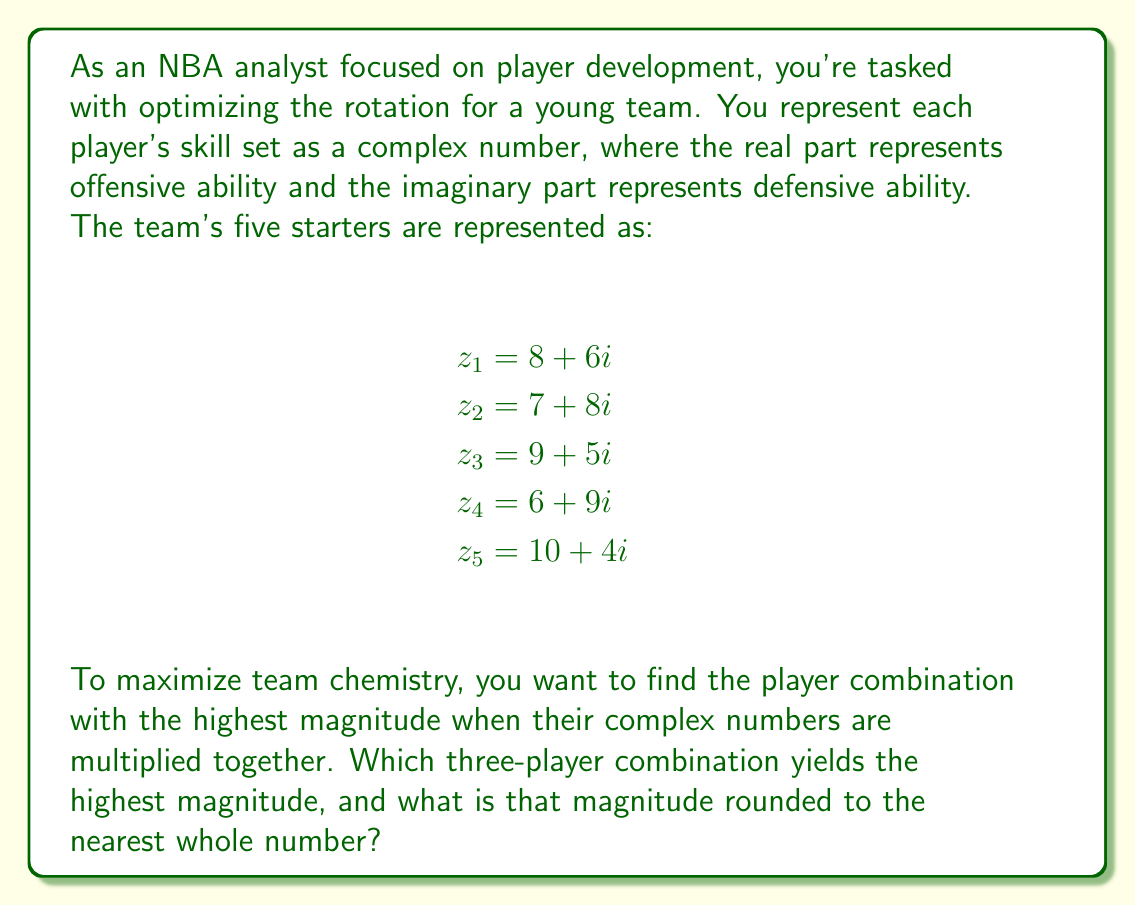Can you answer this question? To solve this problem, we need to:
1. Calculate the magnitude of each three-player combination
2. Compare the magnitudes to find the highest one

The magnitude of a complex number $z = a + bi$ is given by $|z| = \sqrt{a^2 + b^2}$

For a combination of three players, we multiply their complex numbers:
$(a_1 + b_1i)(a_2 + b_2i)(a_3 + b_3i) = (a_1a_2a_3 - a_1b_2b_3 - a_2b_1b_3 - a_3b_1b_2) + (a_1a_2b_3 + a_1a_3b_2 + a_2a_3b_1 - b_1b_2b_3)i$

Let's calculate for each combination:

1) $z_1, z_2, z_3$:
$(8+6i)(7+8i)(9+5i) = (-582 + 1494i)$
$|-582 + 1494i| = \sqrt{(-582)^2 + 1494^2} \approx 1604$

2) $z_1, z_2, z_4$:
$(8+6i)(7+8i)(6+9i) = (-1098 + 1062i)$
$|-1098 + 1062i| = \sqrt{(-1098)^2 + 1062^2} \approx 1526$

3) $z_1, z_2, z_5$:
$(8+6i)(7+8i)(10+4i) = (20 + 1580i)$
$|20 + 1580i| = \sqrt{20^2 + 1580^2} \approx 1580$

4) $z_1, z_3, z_4$:
$(8+6i)(9+5i)(6+9i) = (-702 + 1098i)$
$|-702 + 1098i| = \sqrt{(-702)^2 + 1098^2} \approx 1302$

5) $z_1, z_3, z_5$:
$(8+6i)(9+5i)(10+4i) = (670 + 1330i)$
$|670 + 1330i| = \sqrt{670^2 + 1330^2} \approx 1488$

6) $z_1, z_4, z_5$:
$(8+6i)(6+9i)(10+4i) = (60 + 1300i)$
$|60 + 1300i| = \sqrt{60^2 + 1300^2} \approx 1301$

7) $z_2, z_3, z_4$:
$(7+8i)(9+5i)(6+9i) = (-1089 + 963i)$
$|-1089 + 963i| = \sqrt{(-1089)^2 + 963^2} \approx 1454$

8) $z_2, z_3, z_5$:
$(7+8i)(9+5i)(10+4i) = (490 + 1430i)$
$|490 + 1430i| = \sqrt{490^2 + 1430^2} \approx 1512$

9) $z_2, z_4, z_5$:
$(7+8i)(6+9i)(10+4i) = (-120 + 1580i)$
$|-120 + 1580i| = \sqrt{(-120)^2 + 1580^2} \approx 1585$

10) $z_3, z_4, z_5$:
$(9+5i)(6+9i)(10+4i) = (720 + 1080i)$
$|720 + 1080i| = \sqrt{720^2 + 1080^2} \approx 1296$

The highest magnitude is from the combination of $z_1, z_2, z_3$, which is approximately 1604.
Answer: The three-player combination with the highest magnitude is $z_1, z_2, z_3$ (players 1, 2, and 3), with a magnitude of 1604 when rounded to the nearest whole number. 